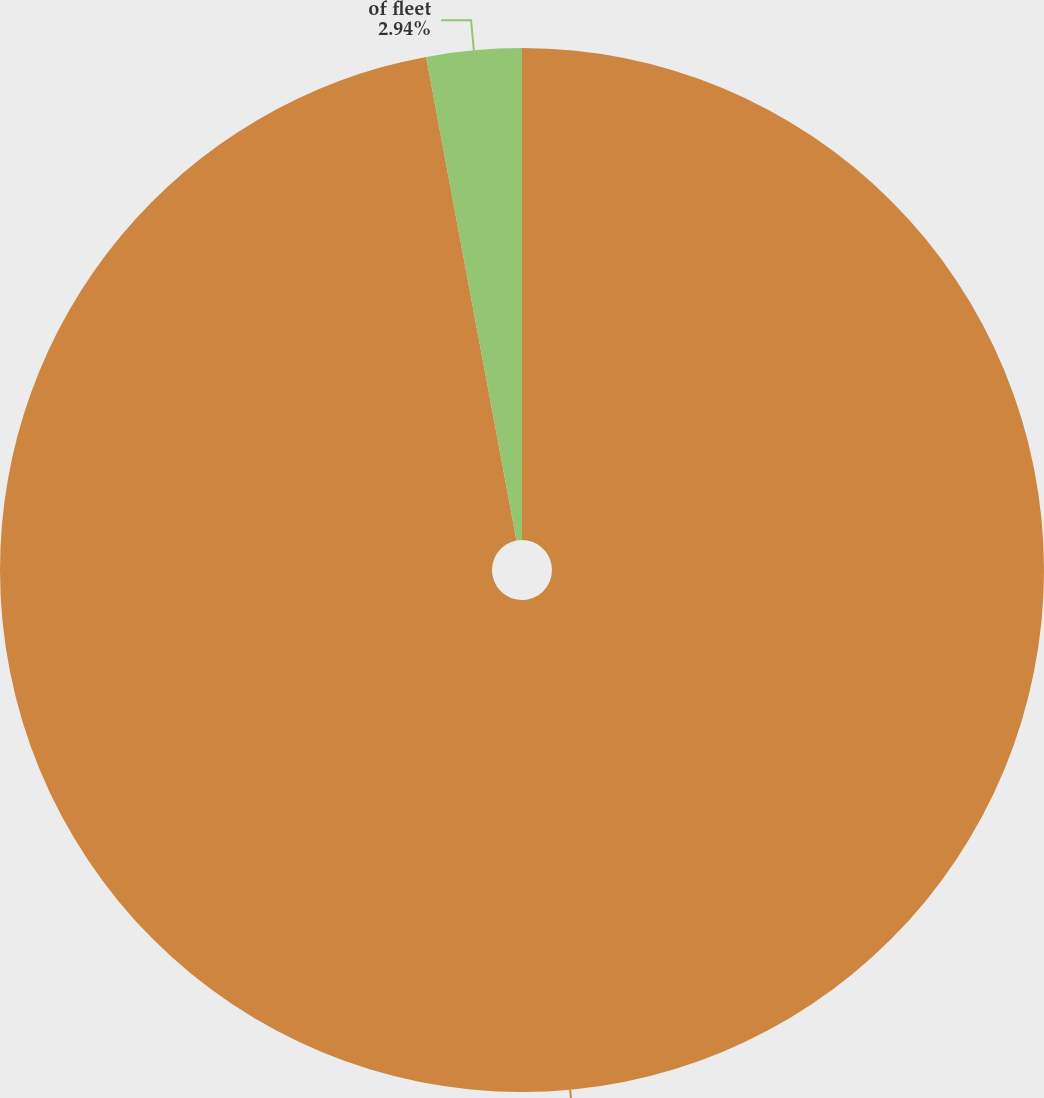<chart> <loc_0><loc_0><loc_500><loc_500><pie_chart><fcel>No of units<fcel>of fleet<nl><fcel>97.06%<fcel>2.94%<nl></chart> 